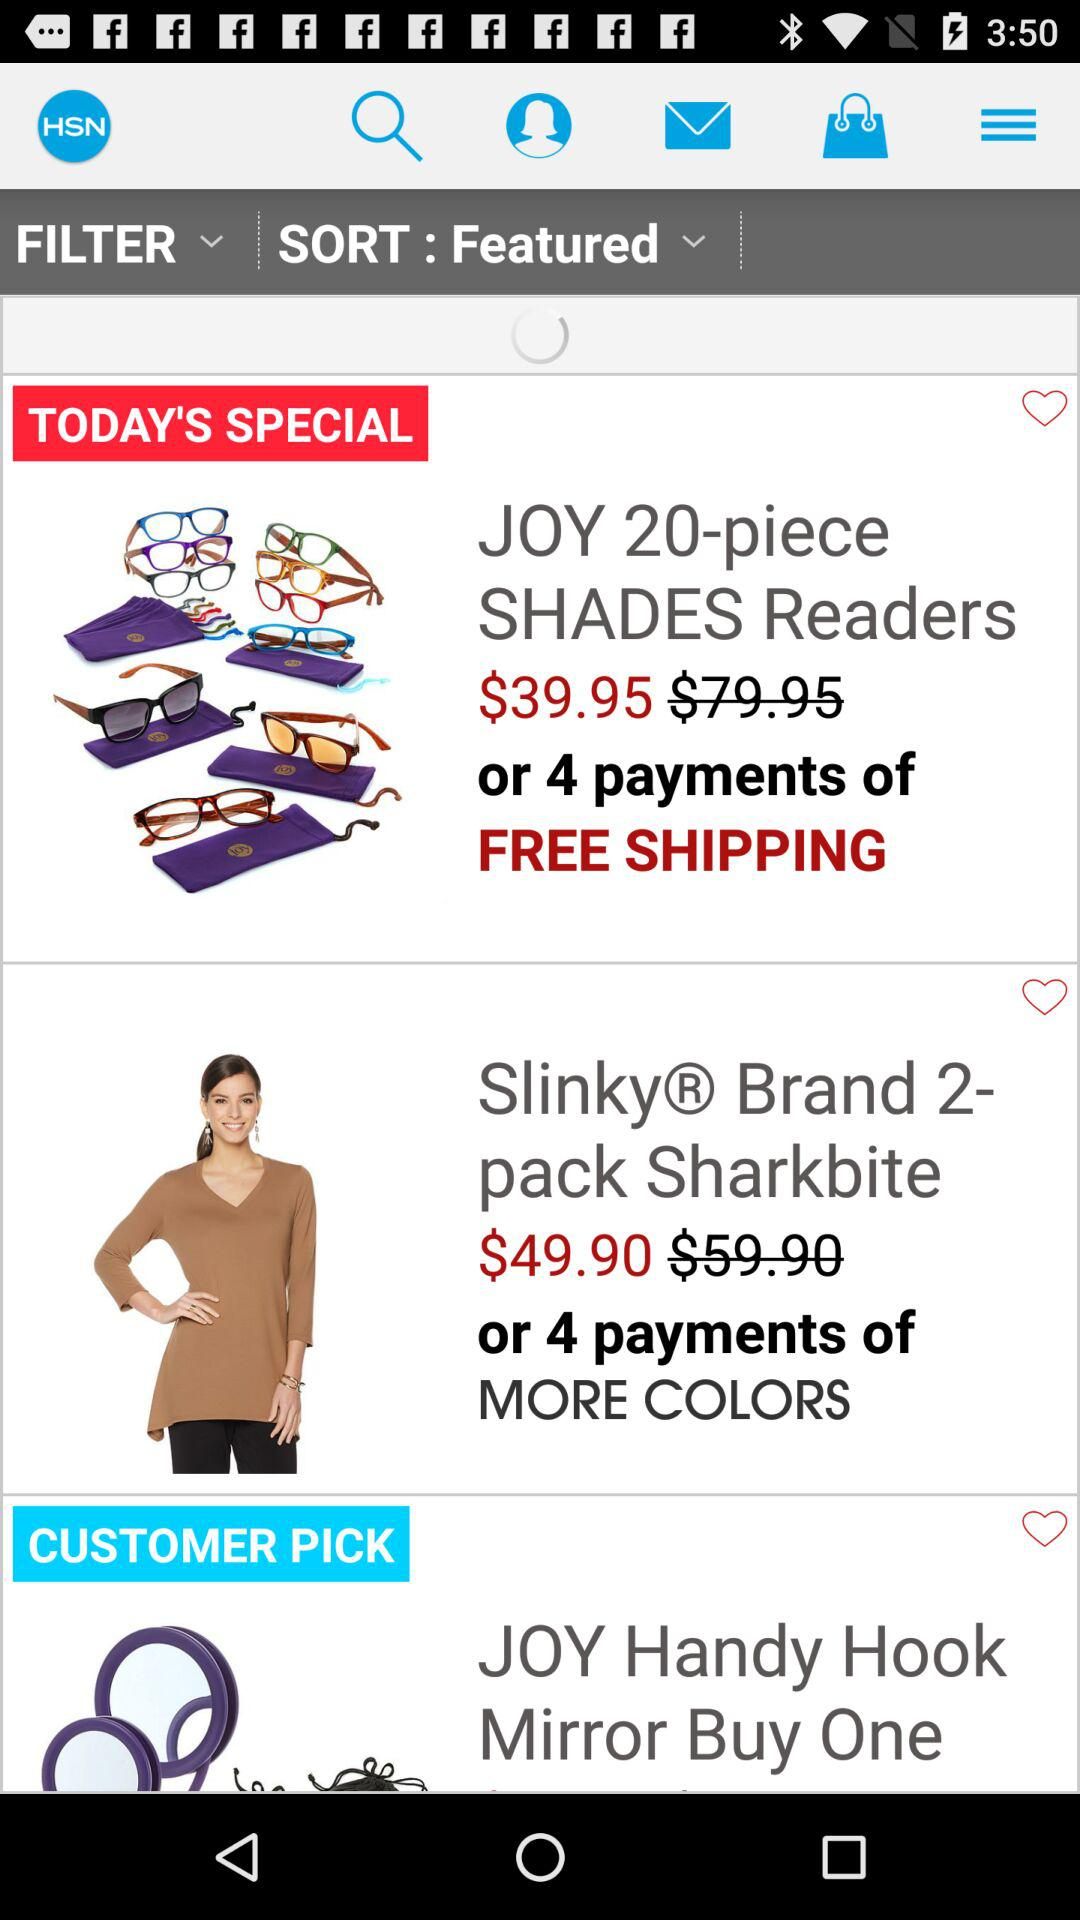Which item will receive free shipping, after making a 4-payment transaction? The item is "JOY 20-piece SHADES Readers". 